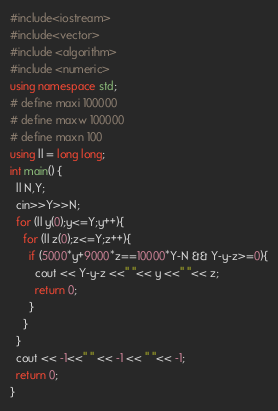<code> <loc_0><loc_0><loc_500><loc_500><_C++_>#include<iostream>
#include<vector>
#include <algorithm>
#include <numeric>
using namespace std;
# define maxi 100000
# define maxw 100000
# define maxn 100
using ll = long long;
int main() {
  ll N,Y;
  cin>>Y>>N;
  for (ll y(0);y<=Y;y++){
    for (ll z(0);z<=Y;z++){
      if (5000*y+9000*z==10000*Y-N && Y-y-z>=0){
        cout << Y-y-z <<" "<< y <<" "<< z;
        return 0;
      }
    }
  }
  cout << -1<<" " << -1 << " "<< -1;
  return 0;
}
</code> 